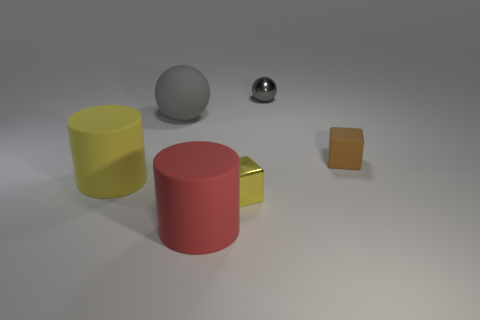There is a rubber cylinder on the right side of the gray ball on the left side of the small metal thing that is behind the tiny brown matte block; what is its color?
Ensure brevity in your answer.  Red. There is a small object that is the same material as the red cylinder; what is its color?
Provide a short and direct response. Brown. What number of objects are brown things that are in front of the matte sphere or objects that are right of the yellow matte thing?
Your answer should be very brief. 5. There is a object on the left side of the big gray thing; does it have the same size as the sphere in front of the small shiny sphere?
Give a very brief answer. Yes. The other object that is the same shape as the red rubber object is what color?
Your answer should be compact. Yellow. Is the number of brown objects that are behind the tiny brown cube greater than the number of tiny things that are right of the tiny metallic block?
Offer a terse response. No. There is a gray sphere that is behind the gray object to the left of the tiny cube that is on the left side of the brown block; what is its size?
Your response must be concise. Small. Do the yellow cylinder and the gray thing on the left side of the tiny gray thing have the same material?
Offer a terse response. Yes. Is the yellow shiny object the same shape as the gray metallic object?
Ensure brevity in your answer.  No. How many other things are there of the same material as the red cylinder?
Offer a very short reply. 3. 